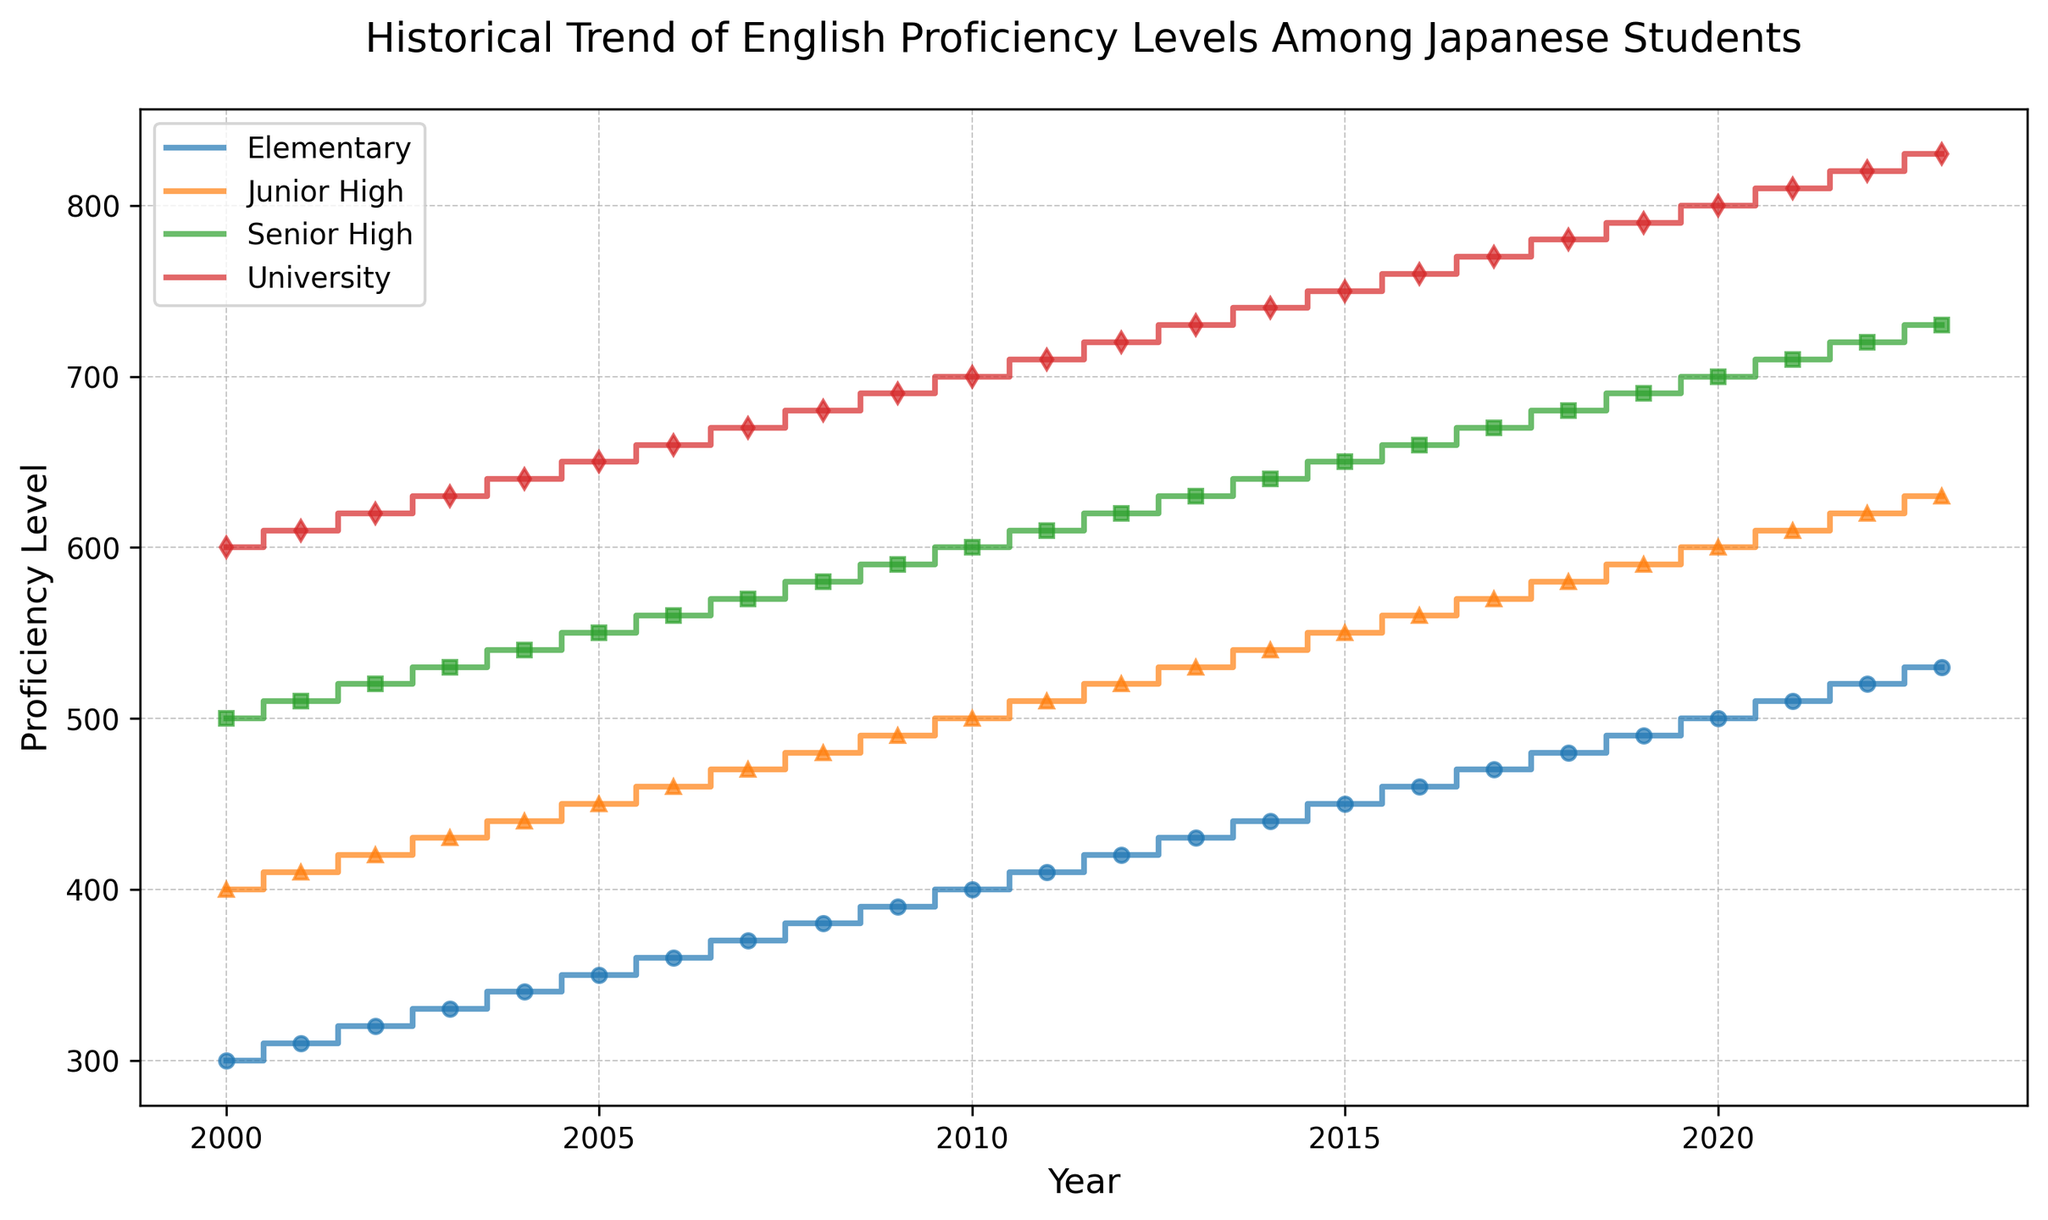What is the overall trend in English proficiency levels among Japanese students from 2000 to 2023? All categories (Elementary, Junior High, Senior High, University) show a continuous upward trend in proficiency levels over the years, reflecting incremental annual increases in scores.
Answer: Upward trend Which educational level had the highest proficiency level in 2023? By looking at the data for 2023, the University level shows the highest proficiency level among the four categories.
Answer: University How much did the proficiency level for Senior High students increase from 2000 to 2023? For 2000, the proficiency level for Senior High is 500, and for 2023, it is 730. The increase is calculated by subtracting the 2000 level from the 2023 level, i.e., 730 - 500.
Answer: 230 Which category had the smallest increment from 2000 to 2023? To find this, we calculate the increments for each category from 2000 to 2023. Elementary: 530-300 = 230; Junior High: 630-400 = 230; Senior High: 730-500 = 230; University: 830-600 = 230. All categories experienced the same increase.
Answer: All categories How do the proficiency levels of Elementary and Senior High students compare in 2010? By looking at the data for 2010, Elementary has a proficiency level of 400, while Senior High has 600. Senior High is higher by 200 points.
Answer: Senior High is higher by 200 What is the average proficiency level for University students from 2000 to 2023? Sum all the values for University students from 2000 to 2023, then divide by the number of years (24). Sum is 600 + 610 + 620 + ... + 810 + 820 + 830 = 17160. Average = 17160 / 24.
Answer: 715 Which year did Junior High students surpass the 500 proficiency level? By looking at the Junior High data, the year when proficiency level first surpasses 500 is 2010.
Answer: 2010 Between 2005 and 2015, which level saw the largest absolute increase in proficiency? By comparing the increases for each category between 2005 and 2015: Elementary: 450 - 350 = 100; Junior High: 550 - 450 = 100; Senior High: 650 - 550 = 100; University: 750 - 650 = 100. All categories saw the same increase.
Answer: All categories Is there any year when the proficiency levels for Elementary and Junior High were the same? No year shows the same proficiency levels for both Elementary and Junior High categories based on the given data.
Answer: No 